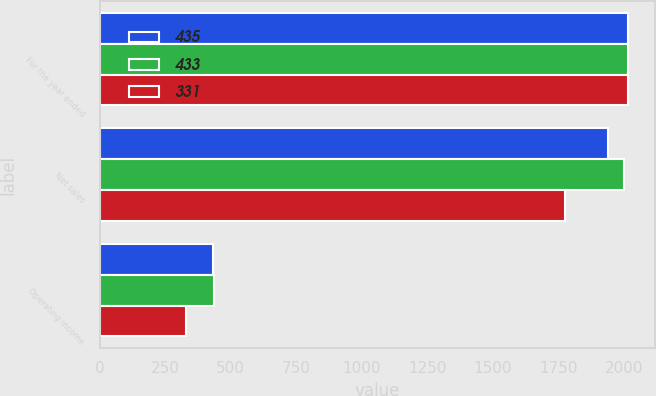Convert chart to OTSL. <chart><loc_0><loc_0><loc_500><loc_500><stacked_bar_chart><ecel><fcel>For the year ended<fcel>Net sales<fcel>Operating income<nl><fcel>435<fcel>2016<fcel>1939<fcel>433<nl><fcel>433<fcel>2015<fcel>1999<fcel>435<nl><fcel>331<fcel>2014<fcel>1774<fcel>331<nl></chart> 